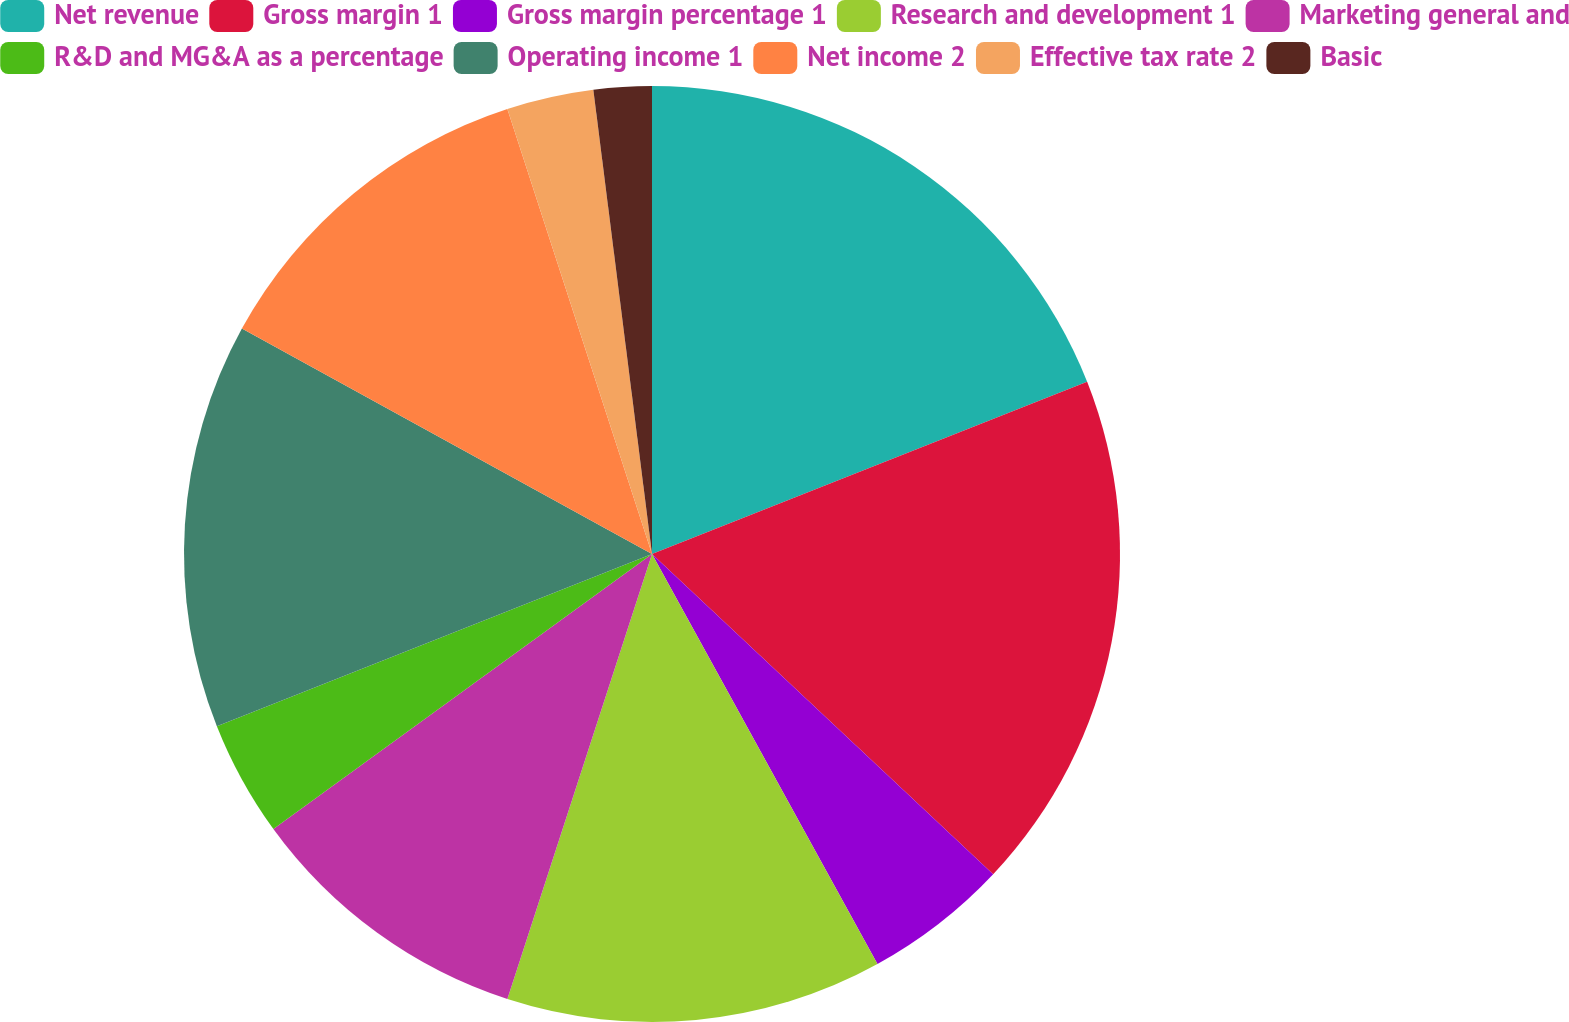Convert chart to OTSL. <chart><loc_0><loc_0><loc_500><loc_500><pie_chart><fcel>Net revenue<fcel>Gross margin 1<fcel>Gross margin percentage 1<fcel>Research and development 1<fcel>Marketing general and<fcel>R&D and MG&A as a percentage<fcel>Operating income 1<fcel>Net income 2<fcel>Effective tax rate 2<fcel>Basic<nl><fcel>19.0%<fcel>18.0%<fcel>5.0%<fcel>13.0%<fcel>10.0%<fcel>4.0%<fcel>14.0%<fcel>12.0%<fcel>3.0%<fcel>2.0%<nl></chart> 